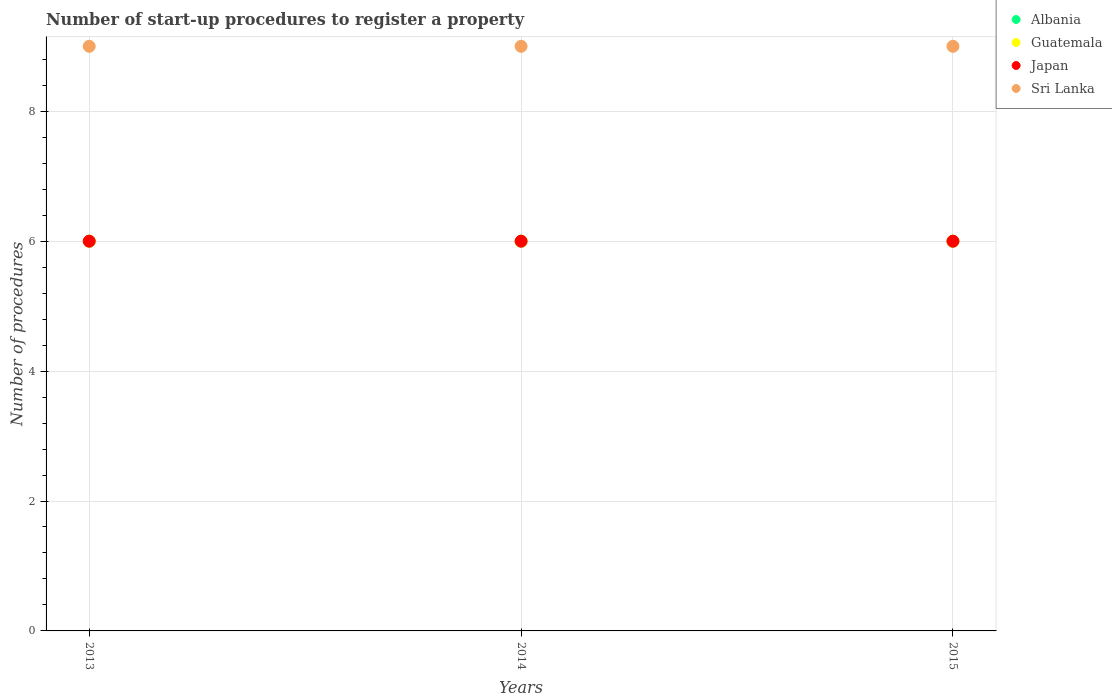How many different coloured dotlines are there?
Your answer should be very brief. 4. What is the number of procedures required to register a property in Sri Lanka in 2013?
Offer a terse response. 9. Across all years, what is the maximum number of procedures required to register a property in Albania?
Ensure brevity in your answer.  6. Across all years, what is the minimum number of procedures required to register a property in Sri Lanka?
Offer a terse response. 9. In which year was the number of procedures required to register a property in Japan maximum?
Provide a succinct answer. 2013. What is the total number of procedures required to register a property in Sri Lanka in the graph?
Offer a very short reply. 27. What is the difference between the number of procedures required to register a property in Albania in 2013 and that in 2014?
Your answer should be compact. 0. In the year 2015, what is the difference between the number of procedures required to register a property in Guatemala and number of procedures required to register a property in Albania?
Provide a short and direct response. 0. In how many years, is the number of procedures required to register a property in Albania greater than 1.2000000000000002?
Provide a succinct answer. 3. Is the number of procedures required to register a property in Japan in 2014 less than that in 2015?
Offer a terse response. No. Is the difference between the number of procedures required to register a property in Guatemala in 2014 and 2015 greater than the difference between the number of procedures required to register a property in Albania in 2014 and 2015?
Provide a short and direct response. No. What is the difference between the highest and the lowest number of procedures required to register a property in Japan?
Keep it short and to the point. 0. In how many years, is the number of procedures required to register a property in Sri Lanka greater than the average number of procedures required to register a property in Sri Lanka taken over all years?
Give a very brief answer. 0. Is it the case that in every year, the sum of the number of procedures required to register a property in Sri Lanka and number of procedures required to register a property in Guatemala  is greater than the sum of number of procedures required to register a property in Japan and number of procedures required to register a property in Albania?
Keep it short and to the point. Yes. Does the number of procedures required to register a property in Albania monotonically increase over the years?
Provide a succinct answer. No. Is the number of procedures required to register a property in Guatemala strictly greater than the number of procedures required to register a property in Sri Lanka over the years?
Your answer should be compact. No. What is the difference between two consecutive major ticks on the Y-axis?
Your answer should be compact. 2. Are the values on the major ticks of Y-axis written in scientific E-notation?
Make the answer very short. No. Does the graph contain any zero values?
Provide a succinct answer. No. Does the graph contain grids?
Your response must be concise. Yes. How many legend labels are there?
Keep it short and to the point. 4. How are the legend labels stacked?
Make the answer very short. Vertical. What is the title of the graph?
Offer a very short reply. Number of start-up procedures to register a property. Does "Papua New Guinea" appear as one of the legend labels in the graph?
Offer a very short reply. No. What is the label or title of the X-axis?
Make the answer very short. Years. What is the label or title of the Y-axis?
Make the answer very short. Number of procedures. What is the Number of procedures of Albania in 2013?
Keep it short and to the point. 6. What is the Number of procedures in Guatemala in 2013?
Offer a very short reply. 6. What is the Number of procedures of Albania in 2014?
Ensure brevity in your answer.  6. What is the Number of procedures of Guatemala in 2014?
Ensure brevity in your answer.  6. What is the Number of procedures in Albania in 2015?
Your response must be concise. 6. What is the Number of procedures of Japan in 2015?
Your answer should be very brief. 6. What is the Number of procedures in Sri Lanka in 2015?
Ensure brevity in your answer.  9. Across all years, what is the maximum Number of procedures of Albania?
Your answer should be compact. 6. Across all years, what is the maximum Number of procedures of Guatemala?
Give a very brief answer. 6. Across all years, what is the maximum Number of procedures of Japan?
Make the answer very short. 6. Across all years, what is the maximum Number of procedures of Sri Lanka?
Provide a succinct answer. 9. Across all years, what is the minimum Number of procedures in Albania?
Provide a succinct answer. 6. Across all years, what is the minimum Number of procedures in Sri Lanka?
Ensure brevity in your answer.  9. What is the total Number of procedures of Guatemala in the graph?
Provide a succinct answer. 18. What is the total Number of procedures in Japan in the graph?
Your answer should be compact. 18. What is the difference between the Number of procedures in Japan in 2013 and that in 2014?
Give a very brief answer. 0. What is the difference between the Number of procedures of Guatemala in 2013 and that in 2015?
Give a very brief answer. 0. What is the difference between the Number of procedures in Japan in 2013 and that in 2015?
Keep it short and to the point. 0. What is the difference between the Number of procedures in Albania in 2014 and that in 2015?
Ensure brevity in your answer.  0. What is the difference between the Number of procedures of Guatemala in 2014 and that in 2015?
Your response must be concise. 0. What is the difference between the Number of procedures of Albania in 2013 and the Number of procedures of Japan in 2014?
Provide a short and direct response. 0. What is the difference between the Number of procedures of Guatemala in 2013 and the Number of procedures of Sri Lanka in 2014?
Keep it short and to the point. -3. What is the difference between the Number of procedures of Japan in 2013 and the Number of procedures of Sri Lanka in 2014?
Offer a very short reply. -3. What is the difference between the Number of procedures in Albania in 2013 and the Number of procedures in Japan in 2015?
Ensure brevity in your answer.  0. What is the difference between the Number of procedures of Guatemala in 2013 and the Number of procedures of Japan in 2015?
Your answer should be compact. 0. What is the difference between the Number of procedures in Guatemala in 2013 and the Number of procedures in Sri Lanka in 2015?
Your answer should be very brief. -3. What is the difference between the Number of procedures in Japan in 2013 and the Number of procedures in Sri Lanka in 2015?
Your answer should be compact. -3. What is the difference between the Number of procedures of Albania in 2014 and the Number of procedures of Guatemala in 2015?
Offer a very short reply. 0. What is the difference between the Number of procedures of Albania in 2014 and the Number of procedures of Sri Lanka in 2015?
Your answer should be compact. -3. What is the average Number of procedures in Albania per year?
Make the answer very short. 6. What is the average Number of procedures in Japan per year?
Give a very brief answer. 6. In the year 2013, what is the difference between the Number of procedures in Albania and Number of procedures in Guatemala?
Offer a terse response. 0. In the year 2013, what is the difference between the Number of procedures in Guatemala and Number of procedures in Sri Lanka?
Your answer should be compact. -3. In the year 2013, what is the difference between the Number of procedures of Japan and Number of procedures of Sri Lanka?
Make the answer very short. -3. In the year 2014, what is the difference between the Number of procedures in Albania and Number of procedures in Guatemala?
Make the answer very short. 0. In the year 2015, what is the difference between the Number of procedures in Albania and Number of procedures in Japan?
Provide a succinct answer. 0. In the year 2015, what is the difference between the Number of procedures of Albania and Number of procedures of Sri Lanka?
Your response must be concise. -3. What is the ratio of the Number of procedures in Albania in 2013 to that in 2014?
Give a very brief answer. 1. What is the ratio of the Number of procedures in Sri Lanka in 2013 to that in 2014?
Your answer should be compact. 1. What is the ratio of the Number of procedures in Albania in 2013 to that in 2015?
Provide a short and direct response. 1. What is the ratio of the Number of procedures in Guatemala in 2013 to that in 2015?
Provide a short and direct response. 1. What is the ratio of the Number of procedures of Sri Lanka in 2013 to that in 2015?
Provide a succinct answer. 1. What is the ratio of the Number of procedures of Albania in 2014 to that in 2015?
Give a very brief answer. 1. What is the ratio of the Number of procedures in Japan in 2014 to that in 2015?
Provide a short and direct response. 1. What is the difference between the highest and the second highest Number of procedures in Japan?
Make the answer very short. 0. What is the difference between the highest and the lowest Number of procedures of Albania?
Your answer should be compact. 0. What is the difference between the highest and the lowest Number of procedures of Guatemala?
Your answer should be very brief. 0. What is the difference between the highest and the lowest Number of procedures of Japan?
Give a very brief answer. 0. What is the difference between the highest and the lowest Number of procedures in Sri Lanka?
Give a very brief answer. 0. 